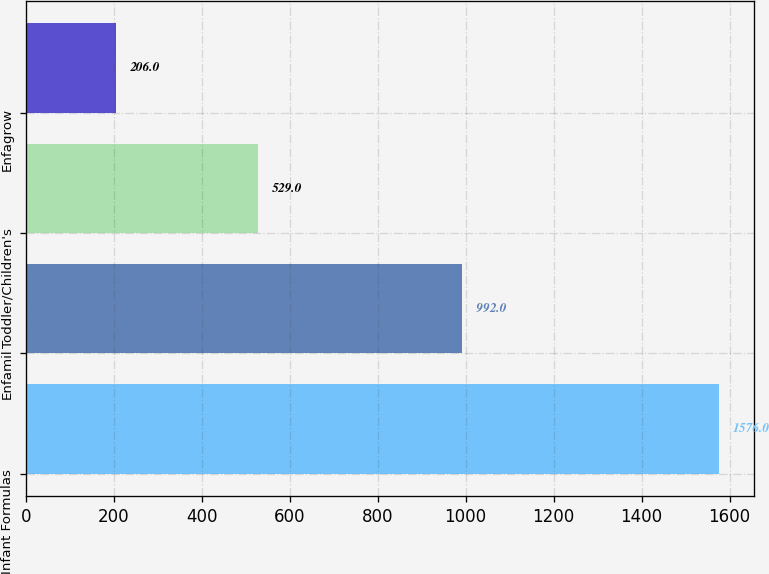Convert chart to OTSL. <chart><loc_0><loc_0><loc_500><loc_500><bar_chart><fcel>Infant Formulas<fcel>Enfamil<fcel>Toddler/Children's<fcel>Enfagrow<nl><fcel>1576<fcel>992<fcel>529<fcel>206<nl></chart> 